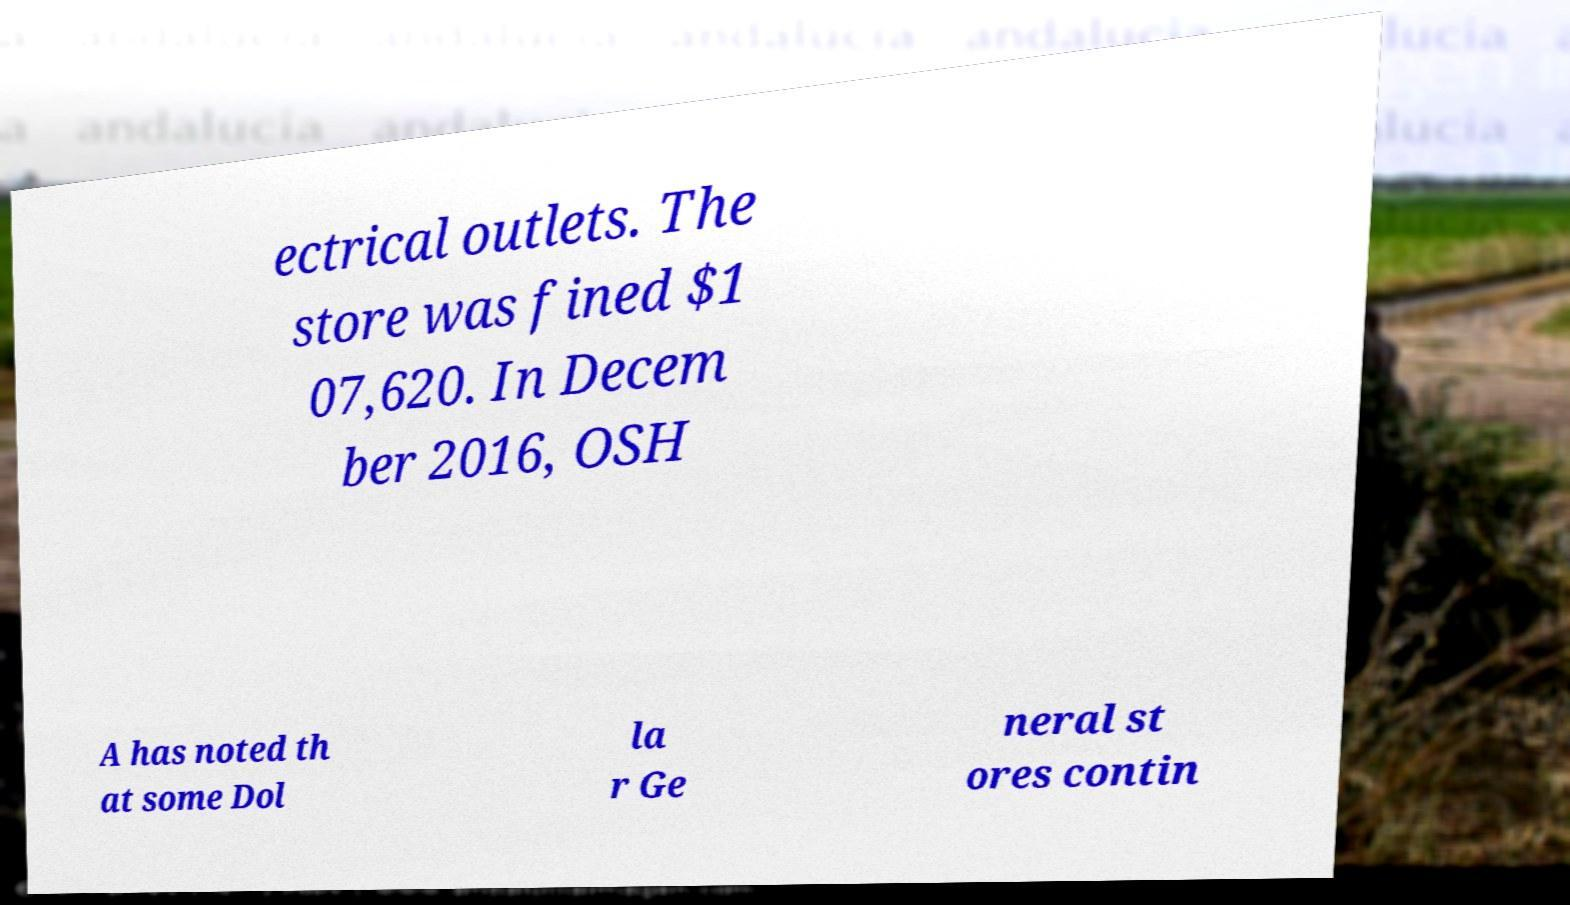Could you extract and type out the text from this image? ectrical outlets. The store was fined $1 07,620. In Decem ber 2016, OSH A has noted th at some Dol la r Ge neral st ores contin 